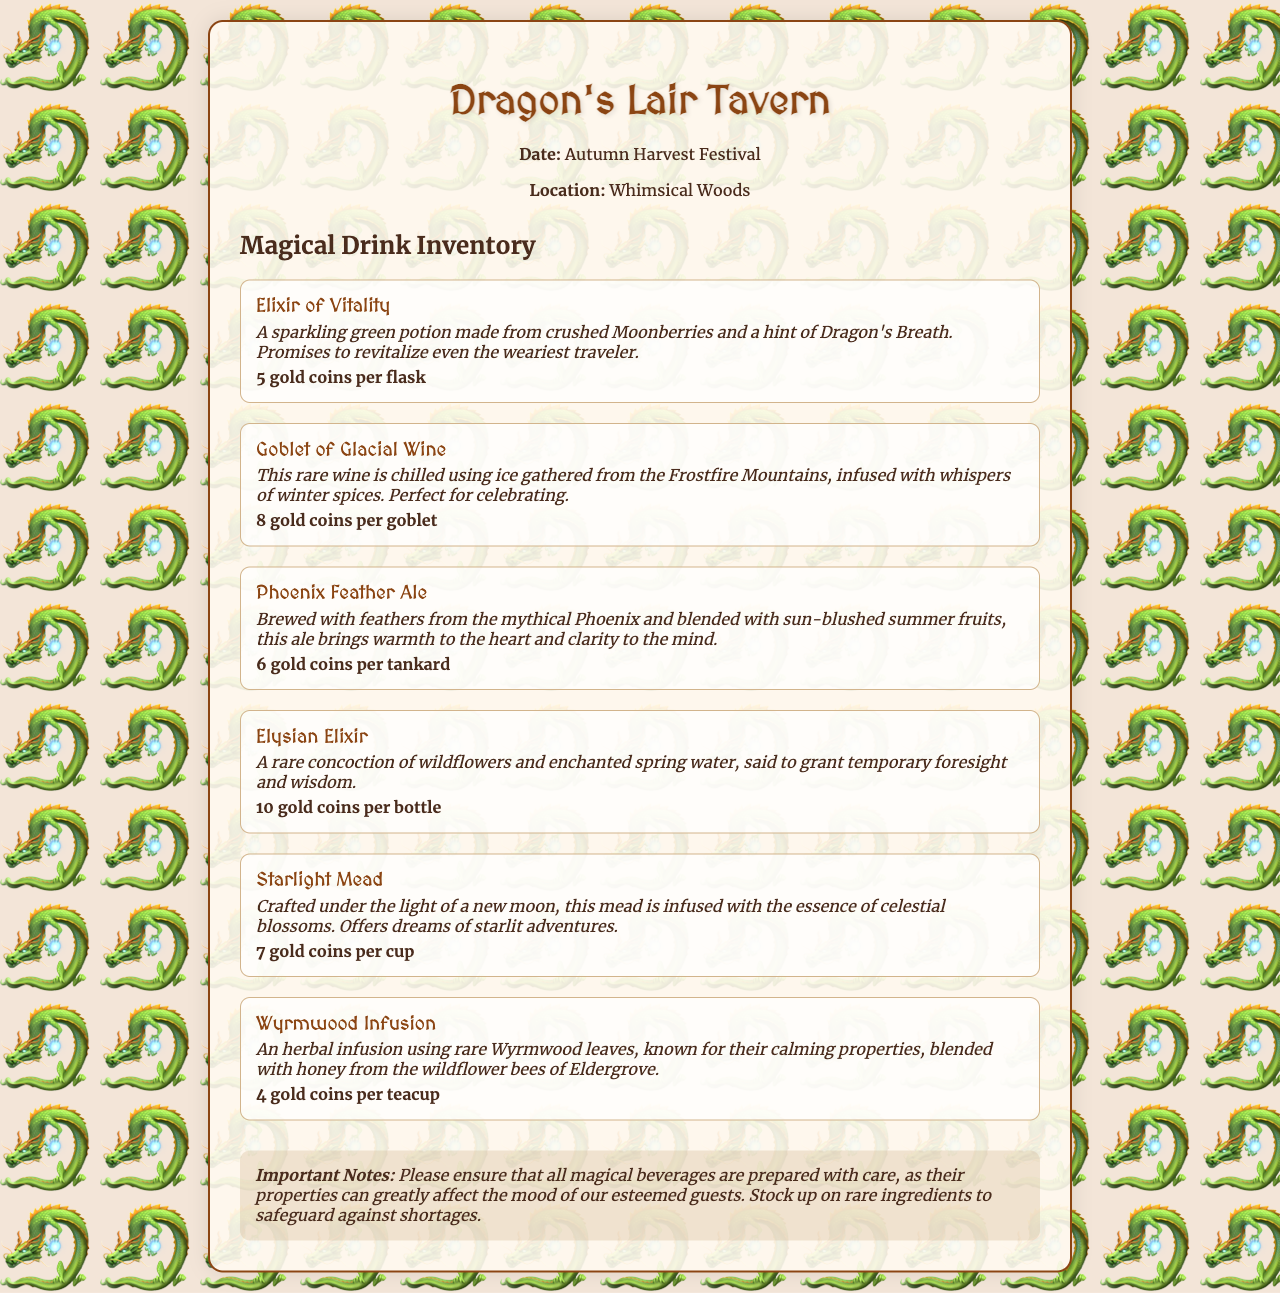What is the date of the inventory? The date mentioned in the document is for the Autumn Harvest Festival.
Answer: Autumn Harvest Festival Where is the Dragon's Lair Tavern located? The location of the Dragon's Lair Tavern is stated as Whimsical Woods.
Answer: Whimsical Woods How much does the Elysian Elixir cost? The cost of the Elysian Elixir is specified as 10 gold coins per bottle.
Answer: 10 gold coins per bottle What drink promises to revitalize even the weariest traveler? The drink that promises revitalization is the Elixir of Vitality.
Answer: Elixir of Vitality Which drink is brewed with Phoenix feathers? The drink brewed with Phoenix feathers is the Phoenix Feather Ale.
Answer: Phoenix Feather Ale How many types of magical drinks are listed in the inventory? The inventory lists a total of six types of magical drinks.
Answer: Six What is the primary reason behind preparing magical beverages with care? The reason for careful preparation is that their properties can greatly affect the mood of the guests.
Answer: Affect the mood of guests What is the price for a goblet of Glacial Wine? The price for a goblet of Glacial Wine is noted as 8 gold coins.
Answer: 8 gold coins What rare ingredient is used in the Wyrmwood Infusion? The Wyrmwood Infusion uses rare Wyrmwood leaves as its primary ingredient.
Answer: Wyrmwood leaves 